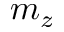<formula> <loc_0><loc_0><loc_500><loc_500>m _ { z }</formula> 